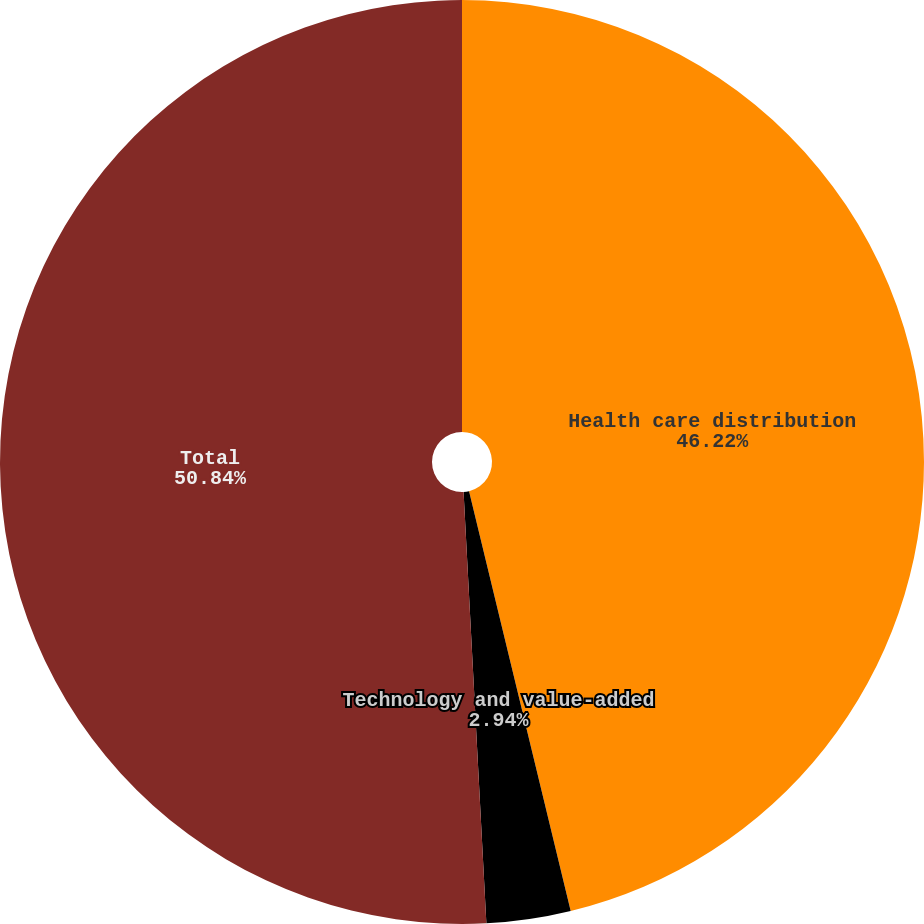<chart> <loc_0><loc_0><loc_500><loc_500><pie_chart><fcel>Health care distribution<fcel>Technology and value-added<fcel>Total<nl><fcel>46.22%<fcel>2.94%<fcel>50.84%<nl></chart> 